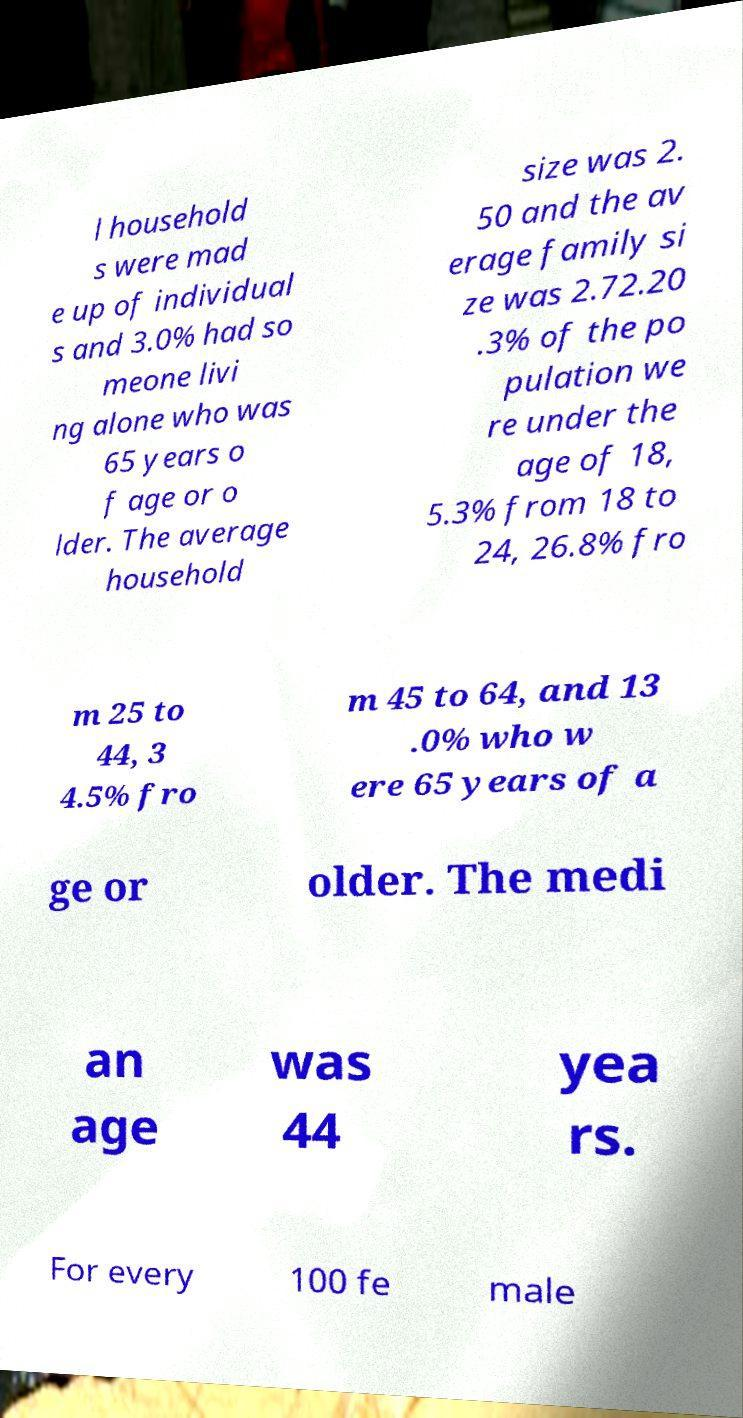Can you accurately transcribe the text from the provided image for me? l household s were mad e up of individual s and 3.0% had so meone livi ng alone who was 65 years o f age or o lder. The average household size was 2. 50 and the av erage family si ze was 2.72.20 .3% of the po pulation we re under the age of 18, 5.3% from 18 to 24, 26.8% fro m 25 to 44, 3 4.5% fro m 45 to 64, and 13 .0% who w ere 65 years of a ge or older. The medi an age was 44 yea rs. For every 100 fe male 